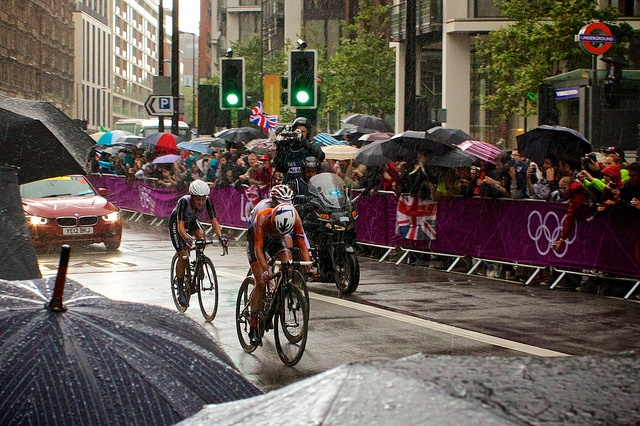Describe the objects in this image and their specific colors. I can see umbrella in maroon, gray, black, darkgray, and lightgray tones, car in maroon, darkgray, white, and black tones, motorcycle in maroon, black, gray, and darkgray tones, bicycle in maroon, black, darkgray, gray, and lightgray tones, and people in maroon, black, gray, and brown tones in this image. 